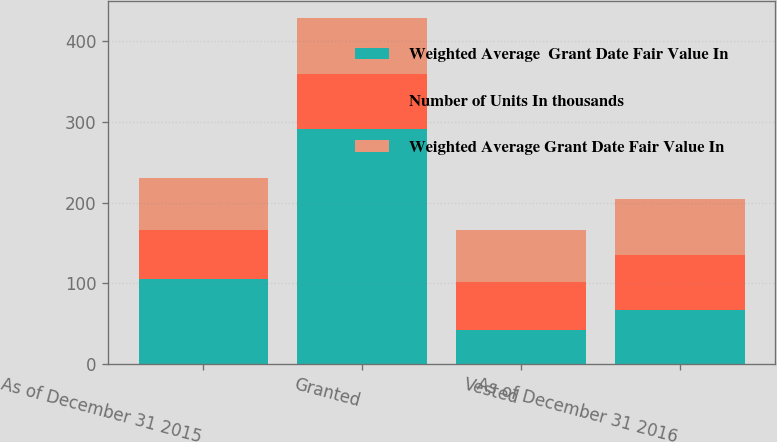<chart> <loc_0><loc_0><loc_500><loc_500><stacked_bar_chart><ecel><fcel>As of December 31 2015<fcel>Granted<fcel>Vested<fcel>As of December 31 2016<nl><fcel>Weighted Average  Grant Date Fair Value In<fcel>105<fcel>291<fcel>42<fcel>67.32<nl><fcel>Number of Units In thousands<fcel>60.78<fcel>67.82<fcel>59.13<fcel>67.32<nl><fcel>Weighted Average Grant Date Fair Value In<fcel>64.94<fcel>69.76<fcel>65.03<fcel>69.88<nl></chart> 